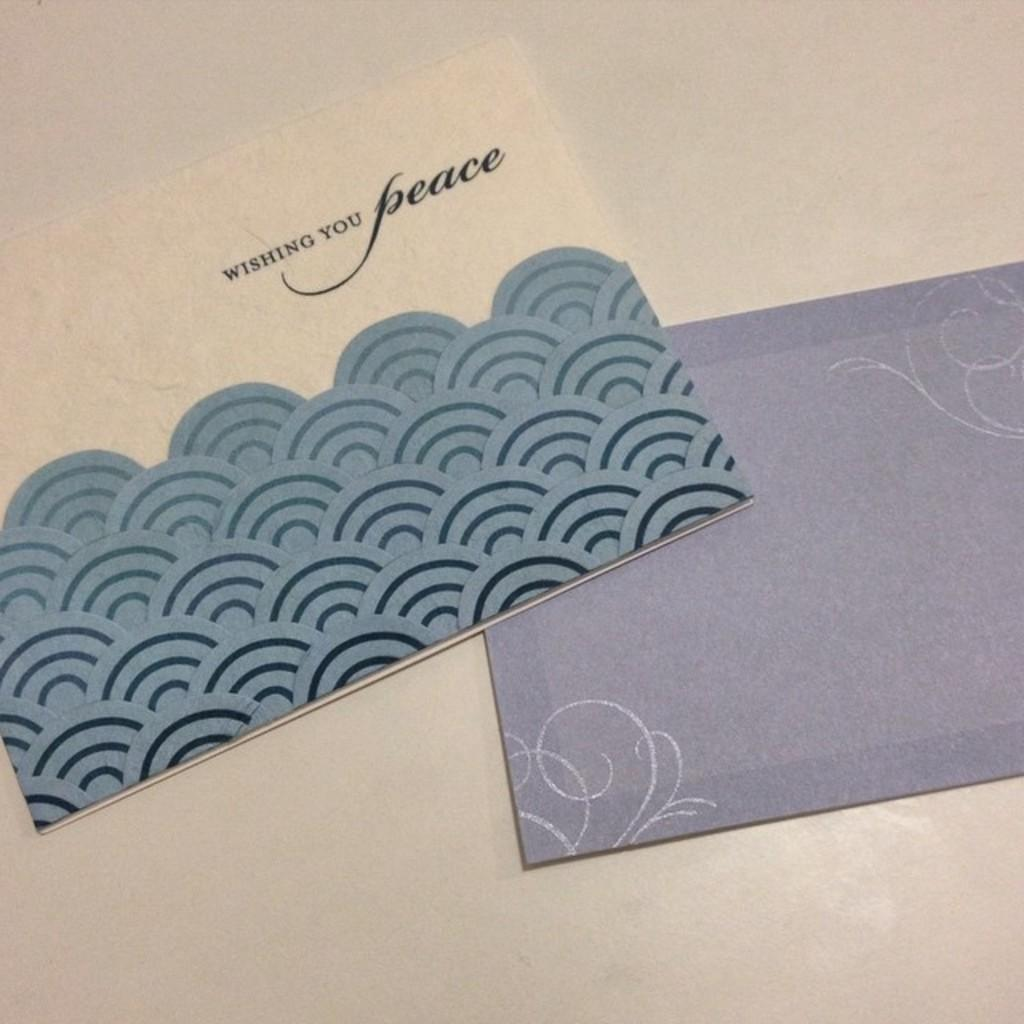Provide a one-sentence caption for the provided image. Wishing you peace card with envelope for it. 